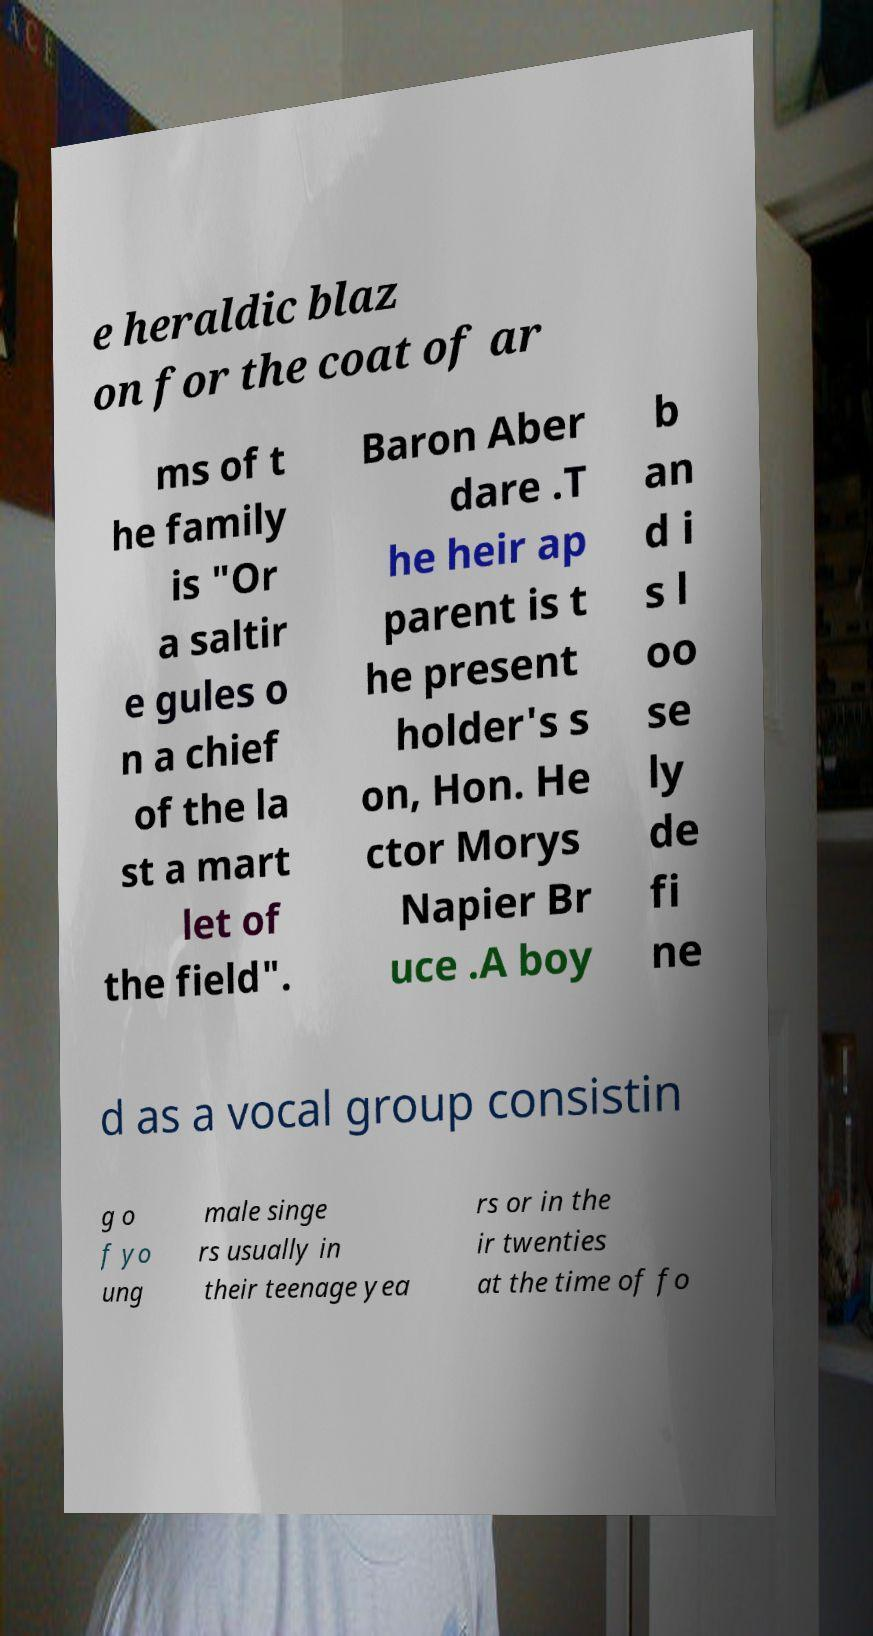Can you read and provide the text displayed in the image?This photo seems to have some interesting text. Can you extract and type it out for me? e heraldic blaz on for the coat of ar ms of t he family is "Or a saltir e gules o n a chief of the la st a mart let of the field". Baron Aber dare .T he heir ap parent is t he present holder's s on, Hon. He ctor Morys Napier Br uce .A boy b an d i s l oo se ly de fi ne d as a vocal group consistin g o f yo ung male singe rs usually in their teenage yea rs or in the ir twenties at the time of fo 